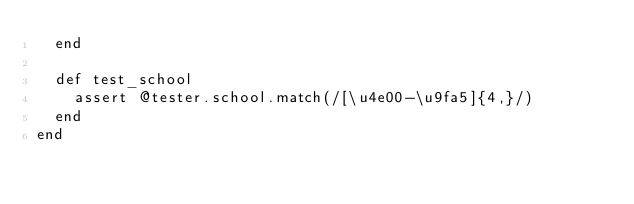<code> <loc_0><loc_0><loc_500><loc_500><_Ruby_>  end

  def test_school
    assert @tester.school.match(/[\u4e00-\u9fa5]{4,}/)
  end
end
</code> 